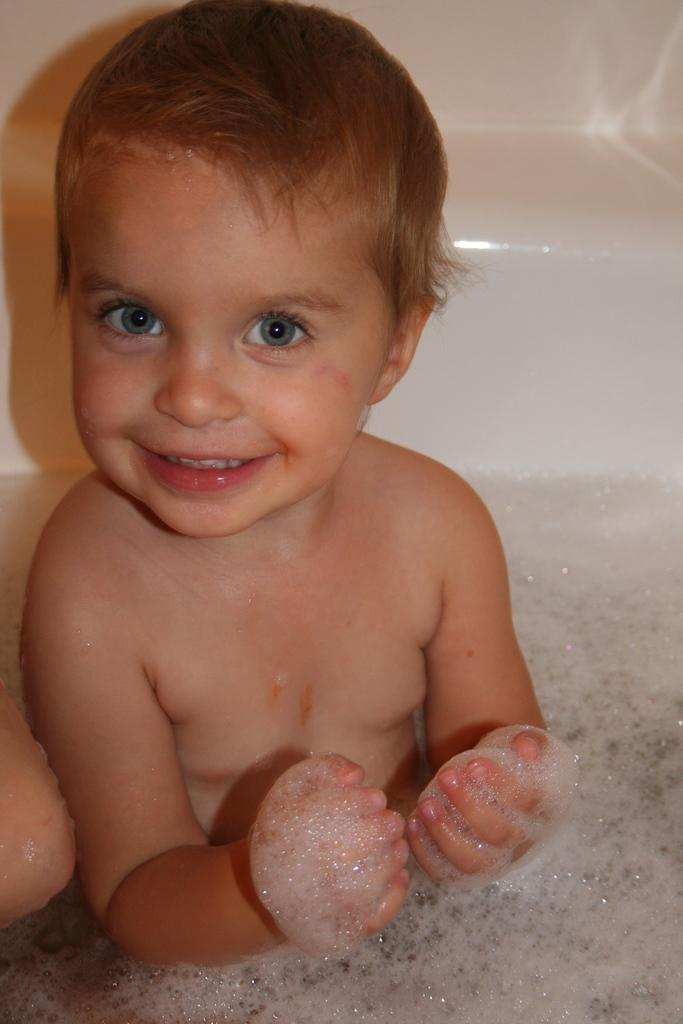What is the main subject of the image? The main subject of the image is a little boy. What is the little boy doing in the image? The little boy is playing in the water. What expression does the little boy have in the image? The little boy is smiling. What part of the little boy's body is being cut by the scissors in the image? There are no scissors present in the image, and therefore no such action is taking place. 